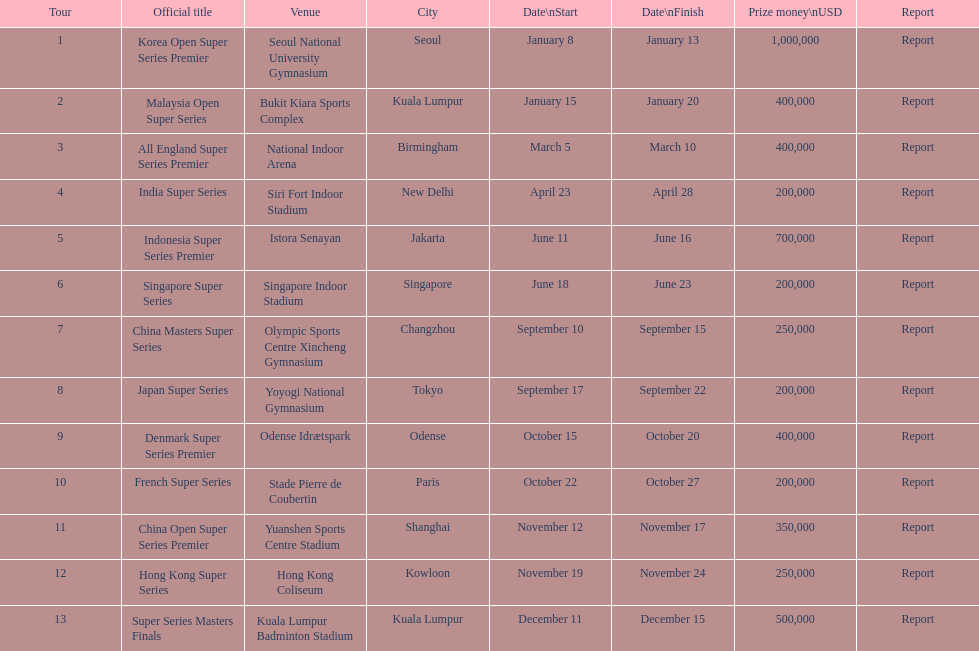Do the winnings for the malaysia open super series exceed or fall short of the french super series? More. 